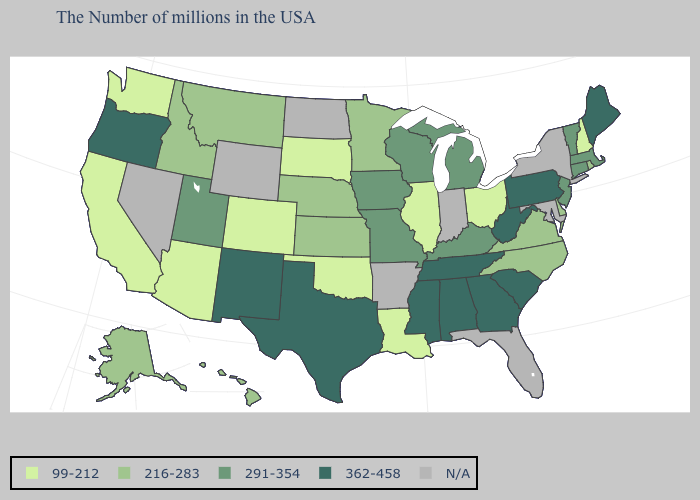Name the states that have a value in the range N/A?
Concise answer only. New York, Maryland, Florida, Indiana, Arkansas, North Dakota, Wyoming, Nevada. What is the highest value in states that border South Dakota?
Quick response, please. 291-354. What is the value of New York?
Keep it brief. N/A. Name the states that have a value in the range N/A?
Short answer required. New York, Maryland, Florida, Indiana, Arkansas, North Dakota, Wyoming, Nevada. Does the map have missing data?
Concise answer only. Yes. What is the value of Maryland?
Quick response, please. N/A. Does Ohio have the highest value in the USA?
Write a very short answer. No. What is the value of Illinois?
Answer briefly. 99-212. Which states have the lowest value in the MidWest?
Concise answer only. Ohio, Illinois, South Dakota. Does New Mexico have the highest value in the West?
Concise answer only. Yes. What is the lowest value in the West?
Be succinct. 99-212. Does South Carolina have the highest value in the USA?
Give a very brief answer. Yes. What is the value of North Dakota?
Answer briefly. N/A. 